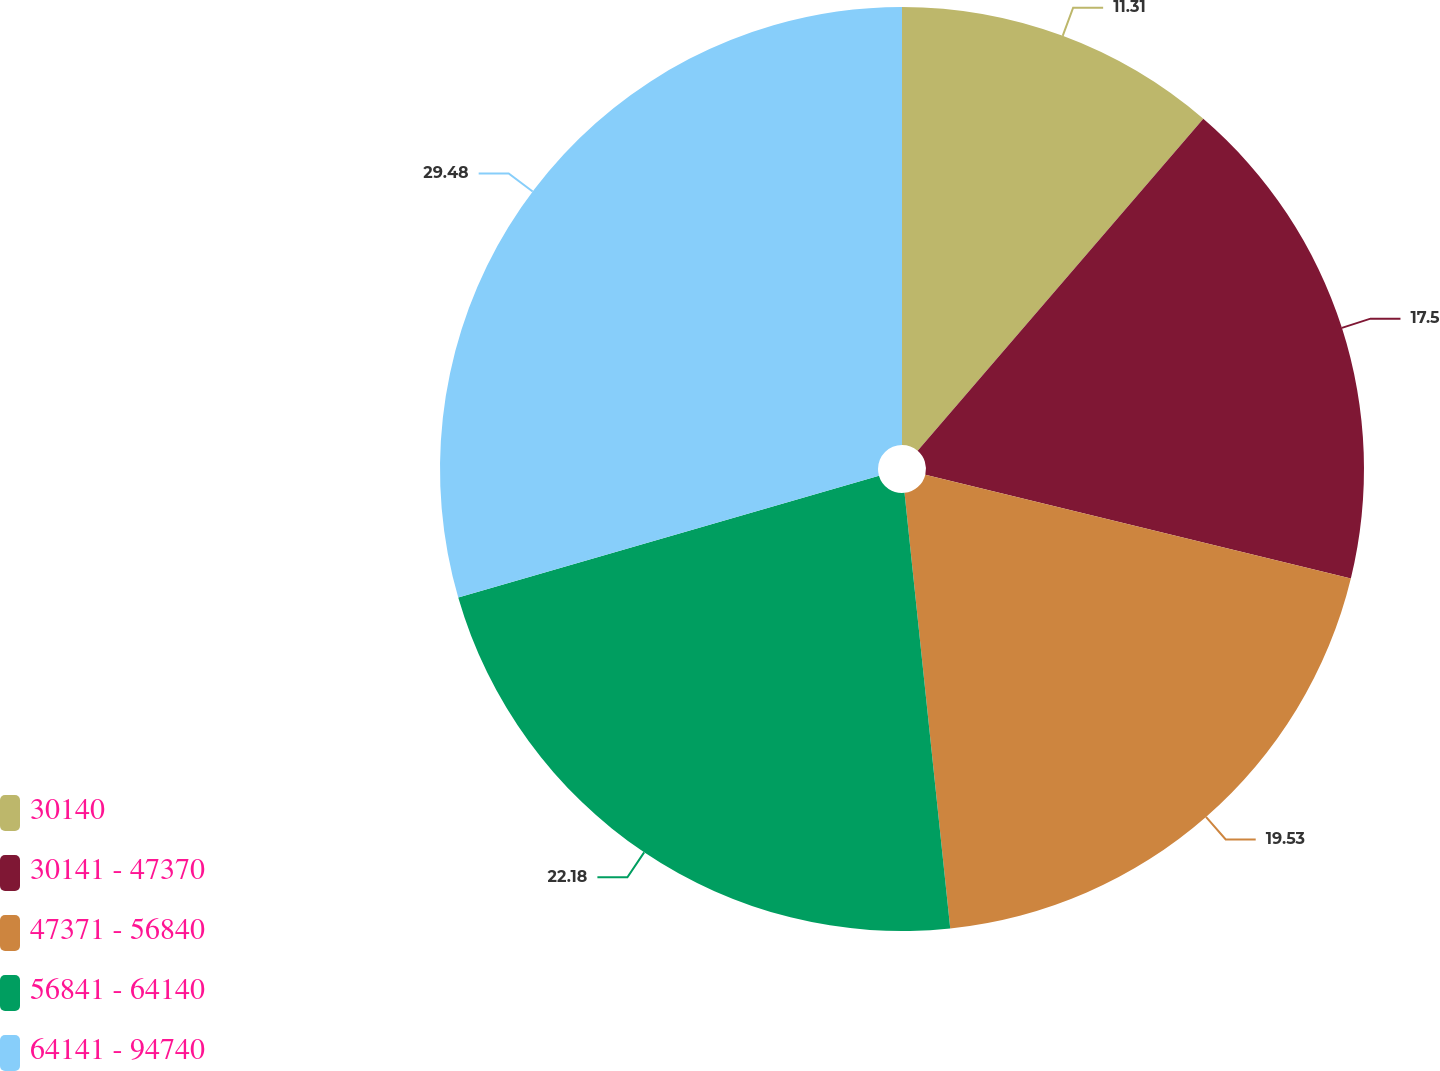<chart> <loc_0><loc_0><loc_500><loc_500><pie_chart><fcel>30140<fcel>30141 - 47370<fcel>47371 - 56840<fcel>56841 - 64140<fcel>64141 - 94740<nl><fcel>11.31%<fcel>17.5%<fcel>19.53%<fcel>22.18%<fcel>29.49%<nl></chart> 